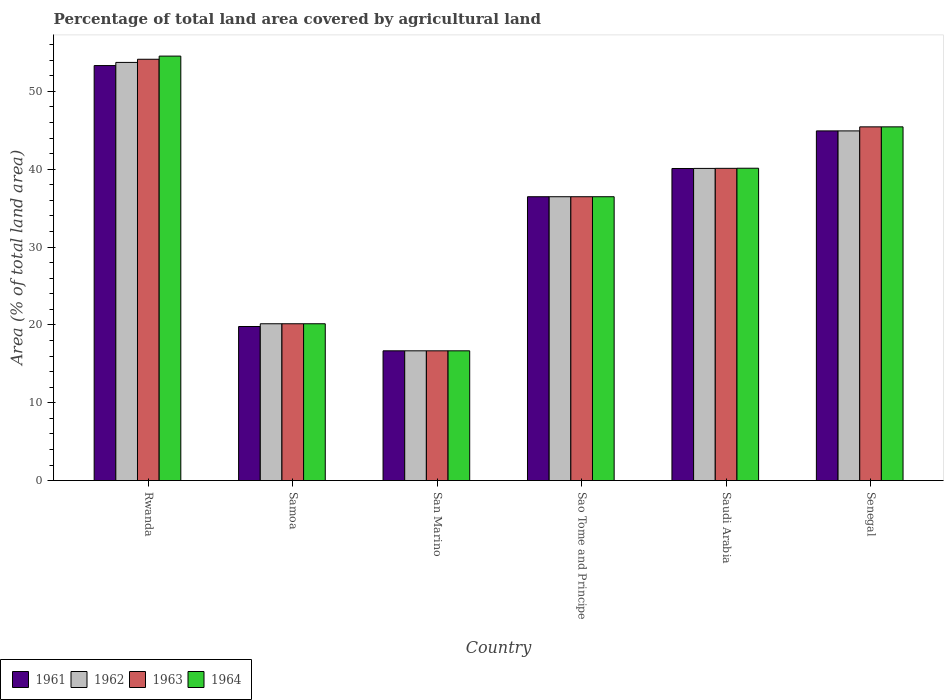Are the number of bars on each tick of the X-axis equal?
Keep it short and to the point. Yes. How many bars are there on the 2nd tick from the right?
Offer a terse response. 4. What is the label of the 5th group of bars from the left?
Your answer should be very brief. Saudi Arabia. In how many cases, is the number of bars for a given country not equal to the number of legend labels?
Your answer should be compact. 0. What is the percentage of agricultural land in 1963 in Senegal?
Offer a terse response. 45.43. Across all countries, what is the maximum percentage of agricultural land in 1961?
Make the answer very short. 53.3. Across all countries, what is the minimum percentage of agricultural land in 1962?
Your response must be concise. 16.67. In which country was the percentage of agricultural land in 1961 maximum?
Provide a succinct answer. Rwanda. In which country was the percentage of agricultural land in 1963 minimum?
Your answer should be compact. San Marino. What is the total percentage of agricultural land in 1961 in the graph?
Make the answer very short. 211.21. What is the difference between the percentage of agricultural land in 1962 in Rwanda and that in San Marino?
Make the answer very short. 37.04. What is the difference between the percentage of agricultural land in 1963 in Senegal and the percentage of agricultural land in 1961 in Rwanda?
Offer a very short reply. -7.87. What is the average percentage of agricultural land in 1962 per country?
Offer a terse response. 35.33. What is the difference between the percentage of agricultural land of/in 1961 and percentage of agricultural land of/in 1962 in Sao Tome and Principe?
Give a very brief answer. 0. In how many countries, is the percentage of agricultural land in 1961 greater than 32 %?
Offer a terse response. 4. What is the ratio of the percentage of agricultural land in 1962 in Rwanda to that in Senegal?
Give a very brief answer. 1.2. Is the percentage of agricultural land in 1962 in Sao Tome and Principe less than that in Saudi Arabia?
Provide a succinct answer. Yes. Is the difference between the percentage of agricultural land in 1961 in San Marino and Saudi Arabia greater than the difference between the percentage of agricultural land in 1962 in San Marino and Saudi Arabia?
Your answer should be compact. Yes. What is the difference between the highest and the second highest percentage of agricultural land in 1964?
Provide a succinct answer. -5.31. What is the difference between the highest and the lowest percentage of agricultural land in 1961?
Your answer should be compact. 36.64. In how many countries, is the percentage of agricultural land in 1961 greater than the average percentage of agricultural land in 1961 taken over all countries?
Your answer should be very brief. 4. What does the 1st bar from the left in San Marino represents?
Offer a terse response. 1961. What does the 2nd bar from the right in Samoa represents?
Your answer should be compact. 1963. How many bars are there?
Provide a short and direct response. 24. Are all the bars in the graph horizontal?
Provide a succinct answer. No. How many countries are there in the graph?
Make the answer very short. 6. Where does the legend appear in the graph?
Ensure brevity in your answer.  Bottom left. How many legend labels are there?
Provide a succinct answer. 4. What is the title of the graph?
Offer a terse response. Percentage of total land area covered by agricultural land. Does "1992" appear as one of the legend labels in the graph?
Keep it short and to the point. No. What is the label or title of the Y-axis?
Keep it short and to the point. Area (% of total land area). What is the Area (% of total land area) of 1961 in Rwanda?
Offer a very short reply. 53.3. What is the Area (% of total land area) of 1962 in Rwanda?
Your answer should be compact. 53.71. What is the Area (% of total land area) in 1963 in Rwanda?
Make the answer very short. 54.11. What is the Area (% of total land area) of 1964 in Rwanda?
Offer a very short reply. 54.52. What is the Area (% of total land area) of 1961 in Samoa?
Provide a succinct answer. 19.79. What is the Area (% of total land area) of 1962 in Samoa?
Your answer should be compact. 20.14. What is the Area (% of total land area) of 1963 in Samoa?
Provide a succinct answer. 20.14. What is the Area (% of total land area) of 1964 in Samoa?
Provide a succinct answer. 20.14. What is the Area (% of total land area) of 1961 in San Marino?
Keep it short and to the point. 16.67. What is the Area (% of total land area) of 1962 in San Marino?
Keep it short and to the point. 16.67. What is the Area (% of total land area) of 1963 in San Marino?
Give a very brief answer. 16.67. What is the Area (% of total land area) in 1964 in San Marino?
Provide a short and direct response. 16.67. What is the Area (% of total land area) of 1961 in Sao Tome and Principe?
Keep it short and to the point. 36.46. What is the Area (% of total land area) of 1962 in Sao Tome and Principe?
Provide a succinct answer. 36.46. What is the Area (% of total land area) of 1963 in Sao Tome and Principe?
Make the answer very short. 36.46. What is the Area (% of total land area) in 1964 in Sao Tome and Principe?
Make the answer very short. 36.46. What is the Area (% of total land area) in 1961 in Saudi Arabia?
Provide a succinct answer. 40.08. What is the Area (% of total land area) of 1962 in Saudi Arabia?
Your answer should be compact. 40.09. What is the Area (% of total land area) of 1963 in Saudi Arabia?
Provide a succinct answer. 40.1. What is the Area (% of total land area) of 1964 in Saudi Arabia?
Give a very brief answer. 40.12. What is the Area (% of total land area) of 1961 in Senegal?
Make the answer very short. 44.91. What is the Area (% of total land area) of 1962 in Senegal?
Your response must be concise. 44.91. What is the Area (% of total land area) of 1963 in Senegal?
Give a very brief answer. 45.43. What is the Area (% of total land area) in 1964 in Senegal?
Keep it short and to the point. 45.43. Across all countries, what is the maximum Area (% of total land area) of 1961?
Provide a short and direct response. 53.3. Across all countries, what is the maximum Area (% of total land area) of 1962?
Provide a succinct answer. 53.71. Across all countries, what is the maximum Area (% of total land area) in 1963?
Ensure brevity in your answer.  54.11. Across all countries, what is the maximum Area (% of total land area) of 1964?
Provide a succinct answer. 54.52. Across all countries, what is the minimum Area (% of total land area) in 1961?
Your answer should be compact. 16.67. Across all countries, what is the minimum Area (% of total land area) of 1962?
Provide a short and direct response. 16.67. Across all countries, what is the minimum Area (% of total land area) of 1963?
Provide a short and direct response. 16.67. Across all countries, what is the minimum Area (% of total land area) of 1964?
Make the answer very short. 16.67. What is the total Area (% of total land area) in 1961 in the graph?
Ensure brevity in your answer.  211.21. What is the total Area (% of total land area) of 1962 in the graph?
Your answer should be compact. 211.98. What is the total Area (% of total land area) in 1963 in the graph?
Provide a succinct answer. 212.92. What is the total Area (% of total land area) in 1964 in the graph?
Provide a succinct answer. 213.34. What is the difference between the Area (% of total land area) of 1961 in Rwanda and that in Samoa?
Give a very brief answer. 33.52. What is the difference between the Area (% of total land area) in 1962 in Rwanda and that in Samoa?
Your answer should be compact. 33.57. What is the difference between the Area (% of total land area) of 1963 in Rwanda and that in Samoa?
Provide a short and direct response. 33.97. What is the difference between the Area (% of total land area) of 1964 in Rwanda and that in Samoa?
Give a very brief answer. 34.38. What is the difference between the Area (% of total land area) of 1961 in Rwanda and that in San Marino?
Provide a short and direct response. 36.64. What is the difference between the Area (% of total land area) of 1962 in Rwanda and that in San Marino?
Give a very brief answer. 37.04. What is the difference between the Area (% of total land area) in 1963 in Rwanda and that in San Marino?
Make the answer very short. 37.45. What is the difference between the Area (% of total land area) in 1964 in Rwanda and that in San Marino?
Provide a short and direct response. 37.85. What is the difference between the Area (% of total land area) of 1961 in Rwanda and that in Sao Tome and Principe?
Your answer should be compact. 16.85. What is the difference between the Area (% of total land area) in 1962 in Rwanda and that in Sao Tome and Principe?
Offer a very short reply. 17.25. What is the difference between the Area (% of total land area) in 1963 in Rwanda and that in Sao Tome and Principe?
Give a very brief answer. 17.66. What is the difference between the Area (% of total land area) of 1964 in Rwanda and that in Sao Tome and Principe?
Make the answer very short. 18.06. What is the difference between the Area (% of total land area) in 1961 in Rwanda and that in Saudi Arabia?
Your answer should be compact. 13.22. What is the difference between the Area (% of total land area) in 1962 in Rwanda and that in Saudi Arabia?
Your response must be concise. 13.61. What is the difference between the Area (% of total land area) of 1963 in Rwanda and that in Saudi Arabia?
Provide a succinct answer. 14.01. What is the difference between the Area (% of total land area) of 1964 in Rwanda and that in Saudi Arabia?
Keep it short and to the point. 14.4. What is the difference between the Area (% of total land area) in 1961 in Rwanda and that in Senegal?
Your answer should be very brief. 8.39. What is the difference between the Area (% of total land area) of 1962 in Rwanda and that in Senegal?
Give a very brief answer. 8.8. What is the difference between the Area (% of total land area) in 1963 in Rwanda and that in Senegal?
Keep it short and to the point. 8.68. What is the difference between the Area (% of total land area) in 1964 in Rwanda and that in Senegal?
Your response must be concise. 9.09. What is the difference between the Area (% of total land area) of 1961 in Samoa and that in San Marino?
Provide a succinct answer. 3.12. What is the difference between the Area (% of total land area) in 1962 in Samoa and that in San Marino?
Offer a very short reply. 3.47. What is the difference between the Area (% of total land area) in 1963 in Samoa and that in San Marino?
Give a very brief answer. 3.47. What is the difference between the Area (% of total land area) of 1964 in Samoa and that in San Marino?
Keep it short and to the point. 3.47. What is the difference between the Area (% of total land area) in 1961 in Samoa and that in Sao Tome and Principe?
Provide a succinct answer. -16.67. What is the difference between the Area (% of total land area) of 1962 in Samoa and that in Sao Tome and Principe?
Your response must be concise. -16.32. What is the difference between the Area (% of total land area) of 1963 in Samoa and that in Sao Tome and Principe?
Offer a very short reply. -16.32. What is the difference between the Area (% of total land area) of 1964 in Samoa and that in Sao Tome and Principe?
Ensure brevity in your answer.  -16.32. What is the difference between the Area (% of total land area) in 1961 in Samoa and that in Saudi Arabia?
Offer a terse response. -20.3. What is the difference between the Area (% of total land area) in 1962 in Samoa and that in Saudi Arabia?
Your answer should be very brief. -19.95. What is the difference between the Area (% of total land area) in 1963 in Samoa and that in Saudi Arabia?
Offer a very short reply. -19.96. What is the difference between the Area (% of total land area) in 1964 in Samoa and that in Saudi Arabia?
Keep it short and to the point. -19.98. What is the difference between the Area (% of total land area) in 1961 in Samoa and that in Senegal?
Ensure brevity in your answer.  -25.12. What is the difference between the Area (% of total land area) of 1962 in Samoa and that in Senegal?
Provide a succinct answer. -24.77. What is the difference between the Area (% of total land area) of 1963 in Samoa and that in Senegal?
Your response must be concise. -25.29. What is the difference between the Area (% of total land area) of 1964 in Samoa and that in Senegal?
Keep it short and to the point. -25.29. What is the difference between the Area (% of total land area) in 1961 in San Marino and that in Sao Tome and Principe?
Your response must be concise. -19.79. What is the difference between the Area (% of total land area) of 1962 in San Marino and that in Sao Tome and Principe?
Provide a succinct answer. -19.79. What is the difference between the Area (% of total land area) in 1963 in San Marino and that in Sao Tome and Principe?
Your answer should be very brief. -19.79. What is the difference between the Area (% of total land area) in 1964 in San Marino and that in Sao Tome and Principe?
Provide a short and direct response. -19.79. What is the difference between the Area (% of total land area) of 1961 in San Marino and that in Saudi Arabia?
Provide a succinct answer. -23.42. What is the difference between the Area (% of total land area) of 1962 in San Marino and that in Saudi Arabia?
Provide a short and direct response. -23.43. What is the difference between the Area (% of total land area) of 1963 in San Marino and that in Saudi Arabia?
Provide a short and direct response. -23.44. What is the difference between the Area (% of total land area) of 1964 in San Marino and that in Saudi Arabia?
Ensure brevity in your answer.  -23.45. What is the difference between the Area (% of total land area) in 1961 in San Marino and that in Senegal?
Ensure brevity in your answer.  -28.25. What is the difference between the Area (% of total land area) of 1962 in San Marino and that in Senegal?
Your response must be concise. -28.25. What is the difference between the Area (% of total land area) in 1963 in San Marino and that in Senegal?
Provide a short and direct response. -28.77. What is the difference between the Area (% of total land area) in 1964 in San Marino and that in Senegal?
Ensure brevity in your answer.  -28.77. What is the difference between the Area (% of total land area) of 1961 in Sao Tome and Principe and that in Saudi Arabia?
Ensure brevity in your answer.  -3.63. What is the difference between the Area (% of total land area) of 1962 in Sao Tome and Principe and that in Saudi Arabia?
Make the answer very short. -3.64. What is the difference between the Area (% of total land area) of 1963 in Sao Tome and Principe and that in Saudi Arabia?
Make the answer very short. -3.65. What is the difference between the Area (% of total land area) in 1964 in Sao Tome and Principe and that in Saudi Arabia?
Keep it short and to the point. -3.66. What is the difference between the Area (% of total land area) of 1961 in Sao Tome and Principe and that in Senegal?
Your response must be concise. -8.45. What is the difference between the Area (% of total land area) of 1962 in Sao Tome and Principe and that in Senegal?
Your response must be concise. -8.45. What is the difference between the Area (% of total land area) of 1963 in Sao Tome and Principe and that in Senegal?
Provide a succinct answer. -8.97. What is the difference between the Area (% of total land area) in 1964 in Sao Tome and Principe and that in Senegal?
Your answer should be compact. -8.97. What is the difference between the Area (% of total land area) in 1961 in Saudi Arabia and that in Senegal?
Provide a short and direct response. -4.83. What is the difference between the Area (% of total land area) of 1962 in Saudi Arabia and that in Senegal?
Offer a terse response. -4.82. What is the difference between the Area (% of total land area) in 1963 in Saudi Arabia and that in Senegal?
Keep it short and to the point. -5.33. What is the difference between the Area (% of total land area) of 1964 in Saudi Arabia and that in Senegal?
Provide a short and direct response. -5.31. What is the difference between the Area (% of total land area) of 1961 in Rwanda and the Area (% of total land area) of 1962 in Samoa?
Ensure brevity in your answer.  33.16. What is the difference between the Area (% of total land area) in 1961 in Rwanda and the Area (% of total land area) in 1963 in Samoa?
Offer a terse response. 33.16. What is the difference between the Area (% of total land area) of 1961 in Rwanda and the Area (% of total land area) of 1964 in Samoa?
Keep it short and to the point. 33.16. What is the difference between the Area (% of total land area) of 1962 in Rwanda and the Area (% of total land area) of 1963 in Samoa?
Give a very brief answer. 33.57. What is the difference between the Area (% of total land area) of 1962 in Rwanda and the Area (% of total land area) of 1964 in Samoa?
Your answer should be very brief. 33.57. What is the difference between the Area (% of total land area) in 1963 in Rwanda and the Area (% of total land area) in 1964 in Samoa?
Make the answer very short. 33.97. What is the difference between the Area (% of total land area) in 1961 in Rwanda and the Area (% of total land area) in 1962 in San Marino?
Give a very brief answer. 36.64. What is the difference between the Area (% of total land area) in 1961 in Rwanda and the Area (% of total land area) in 1963 in San Marino?
Offer a very short reply. 36.64. What is the difference between the Area (% of total land area) of 1961 in Rwanda and the Area (% of total land area) of 1964 in San Marino?
Provide a succinct answer. 36.64. What is the difference between the Area (% of total land area) in 1962 in Rwanda and the Area (% of total land area) in 1963 in San Marino?
Offer a terse response. 37.04. What is the difference between the Area (% of total land area) of 1962 in Rwanda and the Area (% of total land area) of 1964 in San Marino?
Your answer should be compact. 37.04. What is the difference between the Area (% of total land area) in 1963 in Rwanda and the Area (% of total land area) in 1964 in San Marino?
Ensure brevity in your answer.  37.45. What is the difference between the Area (% of total land area) of 1961 in Rwanda and the Area (% of total land area) of 1962 in Sao Tome and Principe?
Provide a short and direct response. 16.85. What is the difference between the Area (% of total land area) in 1961 in Rwanda and the Area (% of total land area) in 1963 in Sao Tome and Principe?
Make the answer very short. 16.85. What is the difference between the Area (% of total land area) in 1961 in Rwanda and the Area (% of total land area) in 1964 in Sao Tome and Principe?
Ensure brevity in your answer.  16.85. What is the difference between the Area (% of total land area) of 1962 in Rwanda and the Area (% of total land area) of 1963 in Sao Tome and Principe?
Ensure brevity in your answer.  17.25. What is the difference between the Area (% of total land area) in 1962 in Rwanda and the Area (% of total land area) in 1964 in Sao Tome and Principe?
Offer a very short reply. 17.25. What is the difference between the Area (% of total land area) in 1963 in Rwanda and the Area (% of total land area) in 1964 in Sao Tome and Principe?
Keep it short and to the point. 17.66. What is the difference between the Area (% of total land area) of 1961 in Rwanda and the Area (% of total land area) of 1962 in Saudi Arabia?
Your response must be concise. 13.21. What is the difference between the Area (% of total land area) in 1961 in Rwanda and the Area (% of total land area) in 1963 in Saudi Arabia?
Keep it short and to the point. 13.2. What is the difference between the Area (% of total land area) of 1961 in Rwanda and the Area (% of total land area) of 1964 in Saudi Arabia?
Your answer should be very brief. 13.19. What is the difference between the Area (% of total land area) of 1962 in Rwanda and the Area (% of total land area) of 1963 in Saudi Arabia?
Your answer should be compact. 13.6. What is the difference between the Area (% of total land area) in 1962 in Rwanda and the Area (% of total land area) in 1964 in Saudi Arabia?
Offer a terse response. 13.59. What is the difference between the Area (% of total land area) in 1963 in Rwanda and the Area (% of total land area) in 1964 in Saudi Arabia?
Offer a very short reply. 14. What is the difference between the Area (% of total land area) in 1961 in Rwanda and the Area (% of total land area) in 1962 in Senegal?
Offer a very short reply. 8.39. What is the difference between the Area (% of total land area) of 1961 in Rwanda and the Area (% of total land area) of 1963 in Senegal?
Offer a very short reply. 7.87. What is the difference between the Area (% of total land area) in 1961 in Rwanda and the Area (% of total land area) in 1964 in Senegal?
Your answer should be very brief. 7.87. What is the difference between the Area (% of total land area) of 1962 in Rwanda and the Area (% of total land area) of 1963 in Senegal?
Offer a terse response. 8.28. What is the difference between the Area (% of total land area) of 1962 in Rwanda and the Area (% of total land area) of 1964 in Senegal?
Provide a short and direct response. 8.28. What is the difference between the Area (% of total land area) of 1963 in Rwanda and the Area (% of total land area) of 1964 in Senegal?
Give a very brief answer. 8.68. What is the difference between the Area (% of total land area) of 1961 in Samoa and the Area (% of total land area) of 1962 in San Marino?
Your answer should be very brief. 3.12. What is the difference between the Area (% of total land area) of 1961 in Samoa and the Area (% of total land area) of 1963 in San Marino?
Provide a succinct answer. 3.12. What is the difference between the Area (% of total land area) of 1961 in Samoa and the Area (% of total land area) of 1964 in San Marino?
Ensure brevity in your answer.  3.12. What is the difference between the Area (% of total land area) of 1962 in Samoa and the Area (% of total land area) of 1963 in San Marino?
Make the answer very short. 3.47. What is the difference between the Area (% of total land area) in 1962 in Samoa and the Area (% of total land area) in 1964 in San Marino?
Offer a terse response. 3.47. What is the difference between the Area (% of total land area) in 1963 in Samoa and the Area (% of total land area) in 1964 in San Marino?
Keep it short and to the point. 3.47. What is the difference between the Area (% of total land area) of 1961 in Samoa and the Area (% of total land area) of 1962 in Sao Tome and Principe?
Your answer should be compact. -16.67. What is the difference between the Area (% of total land area) in 1961 in Samoa and the Area (% of total land area) in 1963 in Sao Tome and Principe?
Offer a very short reply. -16.67. What is the difference between the Area (% of total land area) in 1961 in Samoa and the Area (% of total land area) in 1964 in Sao Tome and Principe?
Offer a very short reply. -16.67. What is the difference between the Area (% of total land area) of 1962 in Samoa and the Area (% of total land area) of 1963 in Sao Tome and Principe?
Provide a succinct answer. -16.32. What is the difference between the Area (% of total land area) in 1962 in Samoa and the Area (% of total land area) in 1964 in Sao Tome and Principe?
Give a very brief answer. -16.32. What is the difference between the Area (% of total land area) of 1963 in Samoa and the Area (% of total land area) of 1964 in Sao Tome and Principe?
Give a very brief answer. -16.32. What is the difference between the Area (% of total land area) of 1961 in Samoa and the Area (% of total land area) of 1962 in Saudi Arabia?
Your answer should be very brief. -20.31. What is the difference between the Area (% of total land area) of 1961 in Samoa and the Area (% of total land area) of 1963 in Saudi Arabia?
Your answer should be very brief. -20.32. What is the difference between the Area (% of total land area) of 1961 in Samoa and the Area (% of total land area) of 1964 in Saudi Arabia?
Provide a succinct answer. -20.33. What is the difference between the Area (% of total land area) in 1962 in Samoa and the Area (% of total land area) in 1963 in Saudi Arabia?
Your answer should be very brief. -19.96. What is the difference between the Area (% of total land area) in 1962 in Samoa and the Area (% of total land area) in 1964 in Saudi Arabia?
Offer a very short reply. -19.98. What is the difference between the Area (% of total land area) in 1963 in Samoa and the Area (% of total land area) in 1964 in Saudi Arabia?
Offer a terse response. -19.98. What is the difference between the Area (% of total land area) of 1961 in Samoa and the Area (% of total land area) of 1962 in Senegal?
Keep it short and to the point. -25.12. What is the difference between the Area (% of total land area) in 1961 in Samoa and the Area (% of total land area) in 1963 in Senegal?
Provide a short and direct response. -25.64. What is the difference between the Area (% of total land area) of 1961 in Samoa and the Area (% of total land area) of 1964 in Senegal?
Your answer should be compact. -25.64. What is the difference between the Area (% of total land area) in 1962 in Samoa and the Area (% of total land area) in 1963 in Senegal?
Provide a short and direct response. -25.29. What is the difference between the Area (% of total land area) in 1962 in Samoa and the Area (% of total land area) in 1964 in Senegal?
Make the answer very short. -25.29. What is the difference between the Area (% of total land area) in 1963 in Samoa and the Area (% of total land area) in 1964 in Senegal?
Your answer should be compact. -25.29. What is the difference between the Area (% of total land area) in 1961 in San Marino and the Area (% of total land area) in 1962 in Sao Tome and Principe?
Your answer should be compact. -19.79. What is the difference between the Area (% of total land area) of 1961 in San Marino and the Area (% of total land area) of 1963 in Sao Tome and Principe?
Keep it short and to the point. -19.79. What is the difference between the Area (% of total land area) in 1961 in San Marino and the Area (% of total land area) in 1964 in Sao Tome and Principe?
Keep it short and to the point. -19.79. What is the difference between the Area (% of total land area) in 1962 in San Marino and the Area (% of total land area) in 1963 in Sao Tome and Principe?
Ensure brevity in your answer.  -19.79. What is the difference between the Area (% of total land area) of 1962 in San Marino and the Area (% of total land area) of 1964 in Sao Tome and Principe?
Your response must be concise. -19.79. What is the difference between the Area (% of total land area) of 1963 in San Marino and the Area (% of total land area) of 1964 in Sao Tome and Principe?
Your answer should be compact. -19.79. What is the difference between the Area (% of total land area) of 1961 in San Marino and the Area (% of total land area) of 1962 in Saudi Arabia?
Offer a terse response. -23.43. What is the difference between the Area (% of total land area) of 1961 in San Marino and the Area (% of total land area) of 1963 in Saudi Arabia?
Provide a short and direct response. -23.44. What is the difference between the Area (% of total land area) of 1961 in San Marino and the Area (% of total land area) of 1964 in Saudi Arabia?
Provide a succinct answer. -23.45. What is the difference between the Area (% of total land area) of 1962 in San Marino and the Area (% of total land area) of 1963 in Saudi Arabia?
Keep it short and to the point. -23.44. What is the difference between the Area (% of total land area) in 1962 in San Marino and the Area (% of total land area) in 1964 in Saudi Arabia?
Your answer should be very brief. -23.45. What is the difference between the Area (% of total land area) in 1963 in San Marino and the Area (% of total land area) in 1964 in Saudi Arabia?
Your response must be concise. -23.45. What is the difference between the Area (% of total land area) of 1961 in San Marino and the Area (% of total land area) of 1962 in Senegal?
Ensure brevity in your answer.  -28.25. What is the difference between the Area (% of total land area) in 1961 in San Marino and the Area (% of total land area) in 1963 in Senegal?
Offer a very short reply. -28.77. What is the difference between the Area (% of total land area) in 1961 in San Marino and the Area (% of total land area) in 1964 in Senegal?
Make the answer very short. -28.77. What is the difference between the Area (% of total land area) in 1962 in San Marino and the Area (% of total land area) in 1963 in Senegal?
Your answer should be compact. -28.77. What is the difference between the Area (% of total land area) of 1962 in San Marino and the Area (% of total land area) of 1964 in Senegal?
Keep it short and to the point. -28.77. What is the difference between the Area (% of total land area) of 1963 in San Marino and the Area (% of total land area) of 1964 in Senegal?
Make the answer very short. -28.77. What is the difference between the Area (% of total land area) of 1961 in Sao Tome and Principe and the Area (% of total land area) of 1962 in Saudi Arabia?
Offer a terse response. -3.64. What is the difference between the Area (% of total land area) in 1961 in Sao Tome and Principe and the Area (% of total land area) in 1963 in Saudi Arabia?
Ensure brevity in your answer.  -3.65. What is the difference between the Area (% of total land area) in 1961 in Sao Tome and Principe and the Area (% of total land area) in 1964 in Saudi Arabia?
Your answer should be very brief. -3.66. What is the difference between the Area (% of total land area) in 1962 in Sao Tome and Principe and the Area (% of total land area) in 1963 in Saudi Arabia?
Make the answer very short. -3.65. What is the difference between the Area (% of total land area) of 1962 in Sao Tome and Principe and the Area (% of total land area) of 1964 in Saudi Arabia?
Offer a terse response. -3.66. What is the difference between the Area (% of total land area) in 1963 in Sao Tome and Principe and the Area (% of total land area) in 1964 in Saudi Arabia?
Your answer should be very brief. -3.66. What is the difference between the Area (% of total land area) in 1961 in Sao Tome and Principe and the Area (% of total land area) in 1962 in Senegal?
Offer a very short reply. -8.45. What is the difference between the Area (% of total land area) of 1961 in Sao Tome and Principe and the Area (% of total land area) of 1963 in Senegal?
Your response must be concise. -8.97. What is the difference between the Area (% of total land area) in 1961 in Sao Tome and Principe and the Area (% of total land area) in 1964 in Senegal?
Your response must be concise. -8.97. What is the difference between the Area (% of total land area) in 1962 in Sao Tome and Principe and the Area (% of total land area) in 1963 in Senegal?
Ensure brevity in your answer.  -8.97. What is the difference between the Area (% of total land area) of 1962 in Sao Tome and Principe and the Area (% of total land area) of 1964 in Senegal?
Give a very brief answer. -8.97. What is the difference between the Area (% of total land area) in 1963 in Sao Tome and Principe and the Area (% of total land area) in 1964 in Senegal?
Offer a terse response. -8.97. What is the difference between the Area (% of total land area) in 1961 in Saudi Arabia and the Area (% of total land area) in 1962 in Senegal?
Your response must be concise. -4.83. What is the difference between the Area (% of total land area) of 1961 in Saudi Arabia and the Area (% of total land area) of 1963 in Senegal?
Give a very brief answer. -5.35. What is the difference between the Area (% of total land area) in 1961 in Saudi Arabia and the Area (% of total land area) in 1964 in Senegal?
Keep it short and to the point. -5.35. What is the difference between the Area (% of total land area) in 1962 in Saudi Arabia and the Area (% of total land area) in 1963 in Senegal?
Keep it short and to the point. -5.34. What is the difference between the Area (% of total land area) of 1962 in Saudi Arabia and the Area (% of total land area) of 1964 in Senegal?
Your response must be concise. -5.34. What is the difference between the Area (% of total land area) in 1963 in Saudi Arabia and the Area (% of total land area) in 1964 in Senegal?
Your response must be concise. -5.33. What is the average Area (% of total land area) in 1961 per country?
Your answer should be compact. 35.2. What is the average Area (% of total land area) in 1962 per country?
Offer a terse response. 35.33. What is the average Area (% of total land area) of 1963 per country?
Keep it short and to the point. 35.49. What is the average Area (% of total land area) of 1964 per country?
Give a very brief answer. 35.56. What is the difference between the Area (% of total land area) of 1961 and Area (% of total land area) of 1962 in Rwanda?
Your answer should be compact. -0.41. What is the difference between the Area (% of total land area) in 1961 and Area (% of total land area) in 1963 in Rwanda?
Provide a short and direct response. -0.81. What is the difference between the Area (% of total land area) in 1961 and Area (% of total land area) in 1964 in Rwanda?
Ensure brevity in your answer.  -1.22. What is the difference between the Area (% of total land area) of 1962 and Area (% of total land area) of 1963 in Rwanda?
Offer a very short reply. -0.41. What is the difference between the Area (% of total land area) of 1962 and Area (% of total land area) of 1964 in Rwanda?
Offer a terse response. -0.81. What is the difference between the Area (% of total land area) in 1963 and Area (% of total land area) in 1964 in Rwanda?
Provide a short and direct response. -0.41. What is the difference between the Area (% of total land area) in 1961 and Area (% of total land area) in 1962 in Samoa?
Provide a short and direct response. -0.35. What is the difference between the Area (% of total land area) of 1961 and Area (% of total land area) of 1963 in Samoa?
Offer a very short reply. -0.35. What is the difference between the Area (% of total land area) of 1961 and Area (% of total land area) of 1964 in Samoa?
Offer a very short reply. -0.35. What is the difference between the Area (% of total land area) of 1962 and Area (% of total land area) of 1963 in Samoa?
Provide a succinct answer. 0. What is the difference between the Area (% of total land area) of 1961 and Area (% of total land area) of 1963 in San Marino?
Provide a short and direct response. 0. What is the difference between the Area (% of total land area) in 1961 and Area (% of total land area) in 1964 in San Marino?
Make the answer very short. 0. What is the difference between the Area (% of total land area) in 1961 and Area (% of total land area) in 1962 in Sao Tome and Principe?
Offer a very short reply. 0. What is the difference between the Area (% of total land area) of 1961 and Area (% of total land area) of 1963 in Sao Tome and Principe?
Your answer should be compact. 0. What is the difference between the Area (% of total land area) in 1961 and Area (% of total land area) in 1964 in Sao Tome and Principe?
Offer a very short reply. 0. What is the difference between the Area (% of total land area) in 1962 and Area (% of total land area) in 1964 in Sao Tome and Principe?
Give a very brief answer. 0. What is the difference between the Area (% of total land area) in 1963 and Area (% of total land area) in 1964 in Sao Tome and Principe?
Provide a succinct answer. 0. What is the difference between the Area (% of total land area) in 1961 and Area (% of total land area) in 1962 in Saudi Arabia?
Ensure brevity in your answer.  -0.01. What is the difference between the Area (% of total land area) in 1961 and Area (% of total land area) in 1963 in Saudi Arabia?
Your answer should be compact. -0.02. What is the difference between the Area (% of total land area) of 1961 and Area (% of total land area) of 1964 in Saudi Arabia?
Offer a very short reply. -0.03. What is the difference between the Area (% of total land area) of 1962 and Area (% of total land area) of 1963 in Saudi Arabia?
Keep it short and to the point. -0.01. What is the difference between the Area (% of total land area) of 1962 and Area (% of total land area) of 1964 in Saudi Arabia?
Your response must be concise. -0.02. What is the difference between the Area (% of total land area) in 1963 and Area (% of total land area) in 1964 in Saudi Arabia?
Keep it short and to the point. -0.01. What is the difference between the Area (% of total land area) in 1961 and Area (% of total land area) in 1963 in Senegal?
Your answer should be very brief. -0.52. What is the difference between the Area (% of total land area) in 1961 and Area (% of total land area) in 1964 in Senegal?
Keep it short and to the point. -0.52. What is the difference between the Area (% of total land area) in 1962 and Area (% of total land area) in 1963 in Senegal?
Ensure brevity in your answer.  -0.52. What is the difference between the Area (% of total land area) of 1962 and Area (% of total land area) of 1964 in Senegal?
Provide a succinct answer. -0.52. What is the difference between the Area (% of total land area) in 1963 and Area (% of total land area) in 1964 in Senegal?
Ensure brevity in your answer.  0. What is the ratio of the Area (% of total land area) in 1961 in Rwanda to that in Samoa?
Ensure brevity in your answer.  2.69. What is the ratio of the Area (% of total land area) in 1962 in Rwanda to that in Samoa?
Your answer should be very brief. 2.67. What is the ratio of the Area (% of total land area) in 1963 in Rwanda to that in Samoa?
Provide a succinct answer. 2.69. What is the ratio of the Area (% of total land area) in 1964 in Rwanda to that in Samoa?
Offer a terse response. 2.71. What is the ratio of the Area (% of total land area) of 1961 in Rwanda to that in San Marino?
Offer a very short reply. 3.2. What is the ratio of the Area (% of total land area) of 1962 in Rwanda to that in San Marino?
Provide a succinct answer. 3.22. What is the ratio of the Area (% of total land area) of 1963 in Rwanda to that in San Marino?
Ensure brevity in your answer.  3.25. What is the ratio of the Area (% of total land area) of 1964 in Rwanda to that in San Marino?
Offer a very short reply. 3.27. What is the ratio of the Area (% of total land area) in 1961 in Rwanda to that in Sao Tome and Principe?
Provide a short and direct response. 1.46. What is the ratio of the Area (% of total land area) in 1962 in Rwanda to that in Sao Tome and Principe?
Ensure brevity in your answer.  1.47. What is the ratio of the Area (% of total land area) in 1963 in Rwanda to that in Sao Tome and Principe?
Your response must be concise. 1.48. What is the ratio of the Area (% of total land area) in 1964 in Rwanda to that in Sao Tome and Principe?
Give a very brief answer. 1.5. What is the ratio of the Area (% of total land area) in 1961 in Rwanda to that in Saudi Arabia?
Your response must be concise. 1.33. What is the ratio of the Area (% of total land area) in 1962 in Rwanda to that in Saudi Arabia?
Your response must be concise. 1.34. What is the ratio of the Area (% of total land area) in 1963 in Rwanda to that in Saudi Arabia?
Offer a terse response. 1.35. What is the ratio of the Area (% of total land area) in 1964 in Rwanda to that in Saudi Arabia?
Your answer should be very brief. 1.36. What is the ratio of the Area (% of total land area) of 1961 in Rwanda to that in Senegal?
Offer a very short reply. 1.19. What is the ratio of the Area (% of total land area) in 1962 in Rwanda to that in Senegal?
Provide a short and direct response. 1.2. What is the ratio of the Area (% of total land area) in 1963 in Rwanda to that in Senegal?
Ensure brevity in your answer.  1.19. What is the ratio of the Area (% of total land area) of 1964 in Rwanda to that in Senegal?
Offer a terse response. 1.2. What is the ratio of the Area (% of total land area) of 1961 in Samoa to that in San Marino?
Provide a short and direct response. 1.19. What is the ratio of the Area (% of total land area) of 1962 in Samoa to that in San Marino?
Your answer should be compact. 1.21. What is the ratio of the Area (% of total land area) of 1963 in Samoa to that in San Marino?
Ensure brevity in your answer.  1.21. What is the ratio of the Area (% of total land area) in 1964 in Samoa to that in San Marino?
Give a very brief answer. 1.21. What is the ratio of the Area (% of total land area) in 1961 in Samoa to that in Sao Tome and Principe?
Your answer should be compact. 0.54. What is the ratio of the Area (% of total land area) of 1962 in Samoa to that in Sao Tome and Principe?
Offer a terse response. 0.55. What is the ratio of the Area (% of total land area) in 1963 in Samoa to that in Sao Tome and Principe?
Keep it short and to the point. 0.55. What is the ratio of the Area (% of total land area) in 1964 in Samoa to that in Sao Tome and Principe?
Ensure brevity in your answer.  0.55. What is the ratio of the Area (% of total land area) in 1961 in Samoa to that in Saudi Arabia?
Your answer should be compact. 0.49. What is the ratio of the Area (% of total land area) of 1962 in Samoa to that in Saudi Arabia?
Provide a short and direct response. 0.5. What is the ratio of the Area (% of total land area) in 1963 in Samoa to that in Saudi Arabia?
Your answer should be very brief. 0.5. What is the ratio of the Area (% of total land area) of 1964 in Samoa to that in Saudi Arabia?
Make the answer very short. 0.5. What is the ratio of the Area (% of total land area) in 1961 in Samoa to that in Senegal?
Give a very brief answer. 0.44. What is the ratio of the Area (% of total land area) of 1962 in Samoa to that in Senegal?
Your response must be concise. 0.45. What is the ratio of the Area (% of total land area) in 1963 in Samoa to that in Senegal?
Keep it short and to the point. 0.44. What is the ratio of the Area (% of total land area) in 1964 in Samoa to that in Senegal?
Keep it short and to the point. 0.44. What is the ratio of the Area (% of total land area) in 1961 in San Marino to that in Sao Tome and Principe?
Give a very brief answer. 0.46. What is the ratio of the Area (% of total land area) of 1962 in San Marino to that in Sao Tome and Principe?
Your response must be concise. 0.46. What is the ratio of the Area (% of total land area) of 1963 in San Marino to that in Sao Tome and Principe?
Your answer should be compact. 0.46. What is the ratio of the Area (% of total land area) of 1964 in San Marino to that in Sao Tome and Principe?
Your answer should be compact. 0.46. What is the ratio of the Area (% of total land area) of 1961 in San Marino to that in Saudi Arabia?
Your response must be concise. 0.42. What is the ratio of the Area (% of total land area) in 1962 in San Marino to that in Saudi Arabia?
Your answer should be very brief. 0.42. What is the ratio of the Area (% of total land area) in 1963 in San Marino to that in Saudi Arabia?
Offer a very short reply. 0.42. What is the ratio of the Area (% of total land area) in 1964 in San Marino to that in Saudi Arabia?
Your answer should be compact. 0.42. What is the ratio of the Area (% of total land area) in 1961 in San Marino to that in Senegal?
Make the answer very short. 0.37. What is the ratio of the Area (% of total land area) in 1962 in San Marino to that in Senegal?
Provide a succinct answer. 0.37. What is the ratio of the Area (% of total land area) of 1963 in San Marino to that in Senegal?
Keep it short and to the point. 0.37. What is the ratio of the Area (% of total land area) of 1964 in San Marino to that in Senegal?
Ensure brevity in your answer.  0.37. What is the ratio of the Area (% of total land area) in 1961 in Sao Tome and Principe to that in Saudi Arabia?
Give a very brief answer. 0.91. What is the ratio of the Area (% of total land area) of 1962 in Sao Tome and Principe to that in Saudi Arabia?
Offer a very short reply. 0.91. What is the ratio of the Area (% of total land area) in 1964 in Sao Tome and Principe to that in Saudi Arabia?
Give a very brief answer. 0.91. What is the ratio of the Area (% of total land area) in 1961 in Sao Tome and Principe to that in Senegal?
Your answer should be compact. 0.81. What is the ratio of the Area (% of total land area) of 1962 in Sao Tome and Principe to that in Senegal?
Offer a terse response. 0.81. What is the ratio of the Area (% of total land area) in 1963 in Sao Tome and Principe to that in Senegal?
Offer a very short reply. 0.8. What is the ratio of the Area (% of total land area) in 1964 in Sao Tome and Principe to that in Senegal?
Your answer should be compact. 0.8. What is the ratio of the Area (% of total land area) of 1961 in Saudi Arabia to that in Senegal?
Offer a very short reply. 0.89. What is the ratio of the Area (% of total land area) of 1962 in Saudi Arabia to that in Senegal?
Offer a very short reply. 0.89. What is the ratio of the Area (% of total land area) of 1963 in Saudi Arabia to that in Senegal?
Your answer should be compact. 0.88. What is the ratio of the Area (% of total land area) in 1964 in Saudi Arabia to that in Senegal?
Give a very brief answer. 0.88. What is the difference between the highest and the second highest Area (% of total land area) in 1961?
Give a very brief answer. 8.39. What is the difference between the highest and the second highest Area (% of total land area) in 1962?
Provide a short and direct response. 8.8. What is the difference between the highest and the second highest Area (% of total land area) of 1963?
Offer a terse response. 8.68. What is the difference between the highest and the second highest Area (% of total land area) of 1964?
Provide a succinct answer. 9.09. What is the difference between the highest and the lowest Area (% of total land area) in 1961?
Offer a very short reply. 36.64. What is the difference between the highest and the lowest Area (% of total land area) in 1962?
Ensure brevity in your answer.  37.04. What is the difference between the highest and the lowest Area (% of total land area) in 1963?
Your response must be concise. 37.45. What is the difference between the highest and the lowest Area (% of total land area) of 1964?
Give a very brief answer. 37.85. 